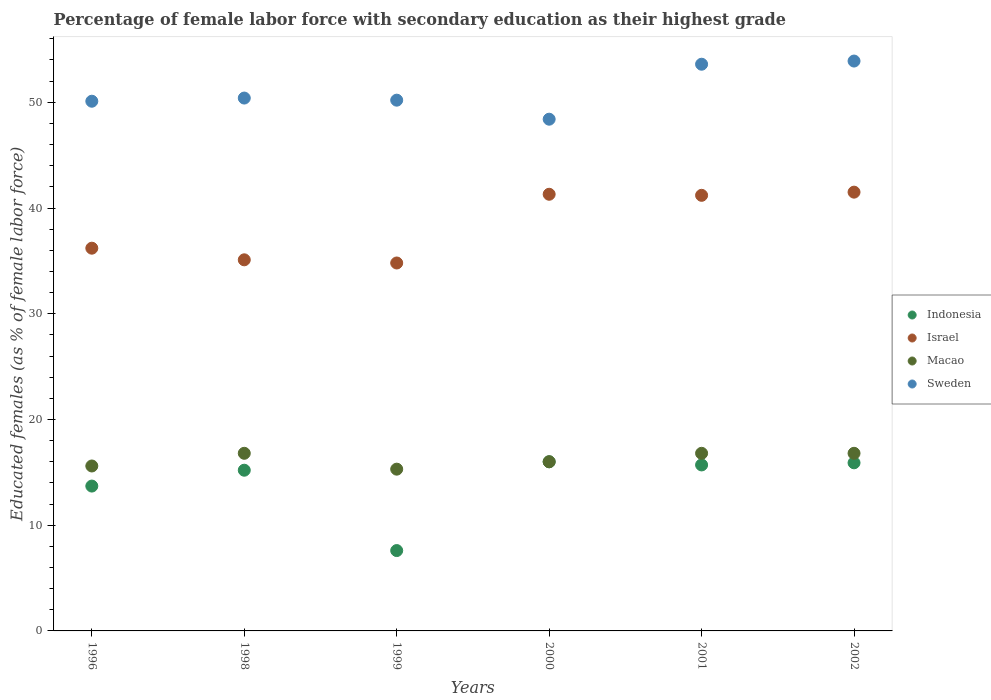How many different coloured dotlines are there?
Offer a very short reply. 4. Is the number of dotlines equal to the number of legend labels?
Give a very brief answer. Yes. What is the percentage of female labor force with secondary education in Israel in 1999?
Your answer should be compact. 34.8. Across all years, what is the maximum percentage of female labor force with secondary education in Sweden?
Your response must be concise. 53.9. Across all years, what is the minimum percentage of female labor force with secondary education in Macao?
Give a very brief answer. 15.3. In which year was the percentage of female labor force with secondary education in Israel minimum?
Offer a terse response. 1999. What is the total percentage of female labor force with secondary education in Israel in the graph?
Provide a short and direct response. 230.1. What is the difference between the percentage of female labor force with secondary education in Israel in 1998 and that in 2000?
Ensure brevity in your answer.  -6.2. What is the difference between the percentage of female labor force with secondary education in Indonesia in 1999 and the percentage of female labor force with secondary education in Israel in 2000?
Offer a terse response. -33.7. What is the average percentage of female labor force with secondary education in Macao per year?
Ensure brevity in your answer.  16.22. In the year 1999, what is the difference between the percentage of female labor force with secondary education in Indonesia and percentage of female labor force with secondary education in Macao?
Offer a very short reply. -7.7. What is the ratio of the percentage of female labor force with secondary education in Indonesia in 1998 to that in 1999?
Offer a very short reply. 2. Is the difference between the percentage of female labor force with secondary education in Indonesia in 1998 and 2001 greater than the difference between the percentage of female labor force with secondary education in Macao in 1998 and 2001?
Offer a very short reply. No. What is the difference between the highest and the second highest percentage of female labor force with secondary education in Indonesia?
Your answer should be compact. 0.1. What is the difference between the highest and the lowest percentage of female labor force with secondary education in Sweden?
Your response must be concise. 5.5. Is it the case that in every year, the sum of the percentage of female labor force with secondary education in Macao and percentage of female labor force with secondary education in Sweden  is greater than the sum of percentage of female labor force with secondary education in Indonesia and percentage of female labor force with secondary education in Israel?
Make the answer very short. Yes. Is it the case that in every year, the sum of the percentage of female labor force with secondary education in Macao and percentage of female labor force with secondary education in Israel  is greater than the percentage of female labor force with secondary education in Sweden?
Your answer should be very brief. No. Does the percentage of female labor force with secondary education in Israel monotonically increase over the years?
Offer a terse response. No. Is the percentage of female labor force with secondary education in Sweden strictly greater than the percentage of female labor force with secondary education in Macao over the years?
Your answer should be compact. Yes. Is the percentage of female labor force with secondary education in Indonesia strictly less than the percentage of female labor force with secondary education in Sweden over the years?
Offer a very short reply. Yes. How many years are there in the graph?
Give a very brief answer. 6. What is the difference between two consecutive major ticks on the Y-axis?
Keep it short and to the point. 10. Are the values on the major ticks of Y-axis written in scientific E-notation?
Your answer should be very brief. No. How are the legend labels stacked?
Provide a succinct answer. Vertical. What is the title of the graph?
Keep it short and to the point. Percentage of female labor force with secondary education as their highest grade. What is the label or title of the X-axis?
Your response must be concise. Years. What is the label or title of the Y-axis?
Give a very brief answer. Educated females (as % of female labor force). What is the Educated females (as % of female labor force) of Indonesia in 1996?
Your response must be concise. 13.7. What is the Educated females (as % of female labor force) of Israel in 1996?
Your answer should be compact. 36.2. What is the Educated females (as % of female labor force) in Macao in 1996?
Make the answer very short. 15.6. What is the Educated females (as % of female labor force) in Sweden in 1996?
Your response must be concise. 50.1. What is the Educated females (as % of female labor force) of Indonesia in 1998?
Provide a succinct answer. 15.2. What is the Educated females (as % of female labor force) of Israel in 1998?
Make the answer very short. 35.1. What is the Educated females (as % of female labor force) in Macao in 1998?
Offer a very short reply. 16.8. What is the Educated females (as % of female labor force) of Sweden in 1998?
Your answer should be very brief. 50.4. What is the Educated females (as % of female labor force) in Indonesia in 1999?
Offer a terse response. 7.6. What is the Educated females (as % of female labor force) of Israel in 1999?
Provide a succinct answer. 34.8. What is the Educated females (as % of female labor force) in Macao in 1999?
Your answer should be very brief. 15.3. What is the Educated females (as % of female labor force) in Sweden in 1999?
Keep it short and to the point. 50.2. What is the Educated females (as % of female labor force) in Indonesia in 2000?
Provide a succinct answer. 16. What is the Educated females (as % of female labor force) of Israel in 2000?
Keep it short and to the point. 41.3. What is the Educated females (as % of female labor force) of Macao in 2000?
Make the answer very short. 16. What is the Educated females (as % of female labor force) of Sweden in 2000?
Keep it short and to the point. 48.4. What is the Educated females (as % of female labor force) of Indonesia in 2001?
Keep it short and to the point. 15.7. What is the Educated females (as % of female labor force) of Israel in 2001?
Make the answer very short. 41.2. What is the Educated females (as % of female labor force) in Macao in 2001?
Offer a very short reply. 16.8. What is the Educated females (as % of female labor force) in Sweden in 2001?
Your answer should be compact. 53.6. What is the Educated females (as % of female labor force) of Indonesia in 2002?
Your answer should be very brief. 15.9. What is the Educated females (as % of female labor force) of Israel in 2002?
Give a very brief answer. 41.5. What is the Educated females (as % of female labor force) in Macao in 2002?
Ensure brevity in your answer.  16.8. What is the Educated females (as % of female labor force) of Sweden in 2002?
Make the answer very short. 53.9. Across all years, what is the maximum Educated females (as % of female labor force) in Indonesia?
Provide a short and direct response. 16. Across all years, what is the maximum Educated females (as % of female labor force) of Israel?
Your answer should be very brief. 41.5. Across all years, what is the maximum Educated females (as % of female labor force) of Macao?
Make the answer very short. 16.8. Across all years, what is the maximum Educated females (as % of female labor force) in Sweden?
Provide a short and direct response. 53.9. Across all years, what is the minimum Educated females (as % of female labor force) in Indonesia?
Keep it short and to the point. 7.6. Across all years, what is the minimum Educated females (as % of female labor force) of Israel?
Provide a short and direct response. 34.8. Across all years, what is the minimum Educated females (as % of female labor force) of Macao?
Provide a short and direct response. 15.3. Across all years, what is the minimum Educated females (as % of female labor force) of Sweden?
Your response must be concise. 48.4. What is the total Educated females (as % of female labor force) in Indonesia in the graph?
Offer a very short reply. 84.1. What is the total Educated females (as % of female labor force) of Israel in the graph?
Give a very brief answer. 230.1. What is the total Educated females (as % of female labor force) in Macao in the graph?
Your response must be concise. 97.3. What is the total Educated females (as % of female labor force) in Sweden in the graph?
Your response must be concise. 306.6. What is the difference between the Educated females (as % of female labor force) in Indonesia in 1996 and that in 1998?
Provide a short and direct response. -1.5. What is the difference between the Educated females (as % of female labor force) of Israel in 1996 and that in 1998?
Offer a terse response. 1.1. What is the difference between the Educated females (as % of female labor force) of Macao in 1996 and that in 1998?
Offer a very short reply. -1.2. What is the difference between the Educated females (as % of female labor force) of Sweden in 1996 and that in 1998?
Offer a very short reply. -0.3. What is the difference between the Educated females (as % of female labor force) in Macao in 1996 and that in 1999?
Provide a short and direct response. 0.3. What is the difference between the Educated females (as % of female labor force) of Sweden in 1996 and that in 1999?
Ensure brevity in your answer.  -0.1. What is the difference between the Educated females (as % of female labor force) in Macao in 1996 and that in 2000?
Provide a succinct answer. -0.4. What is the difference between the Educated females (as % of female labor force) of Sweden in 1996 and that in 2000?
Provide a short and direct response. 1.7. What is the difference between the Educated females (as % of female labor force) in Macao in 1996 and that in 2001?
Provide a succinct answer. -1.2. What is the difference between the Educated females (as % of female labor force) in Sweden in 1996 and that in 2001?
Your answer should be very brief. -3.5. What is the difference between the Educated females (as % of female labor force) in Sweden in 1996 and that in 2002?
Keep it short and to the point. -3.8. What is the difference between the Educated females (as % of female labor force) in Indonesia in 1998 and that in 1999?
Your answer should be very brief. 7.6. What is the difference between the Educated females (as % of female labor force) of Israel in 1998 and that in 1999?
Offer a very short reply. 0.3. What is the difference between the Educated females (as % of female labor force) in Indonesia in 1998 and that in 2000?
Make the answer very short. -0.8. What is the difference between the Educated females (as % of female labor force) of Sweden in 1998 and that in 2000?
Make the answer very short. 2. What is the difference between the Educated females (as % of female labor force) in Indonesia in 1998 and that in 2001?
Offer a terse response. -0.5. What is the difference between the Educated females (as % of female labor force) in Sweden in 1998 and that in 2001?
Your answer should be very brief. -3.2. What is the difference between the Educated females (as % of female labor force) in Indonesia in 1998 and that in 2002?
Give a very brief answer. -0.7. What is the difference between the Educated females (as % of female labor force) of Israel in 1998 and that in 2002?
Your answer should be very brief. -6.4. What is the difference between the Educated females (as % of female labor force) of Macao in 1999 and that in 2000?
Give a very brief answer. -0.7. What is the difference between the Educated females (as % of female labor force) in Indonesia in 1999 and that in 2001?
Your answer should be compact. -8.1. What is the difference between the Educated females (as % of female labor force) of Macao in 1999 and that in 2001?
Provide a succinct answer. -1.5. What is the difference between the Educated females (as % of female labor force) in Sweden in 1999 and that in 2001?
Provide a short and direct response. -3.4. What is the difference between the Educated females (as % of female labor force) of Indonesia in 1999 and that in 2002?
Your answer should be compact. -8.3. What is the difference between the Educated females (as % of female labor force) of Israel in 1999 and that in 2002?
Ensure brevity in your answer.  -6.7. What is the difference between the Educated females (as % of female labor force) in Macao in 1999 and that in 2002?
Offer a very short reply. -1.5. What is the difference between the Educated females (as % of female labor force) of Sweden in 1999 and that in 2002?
Provide a succinct answer. -3.7. What is the difference between the Educated females (as % of female labor force) in Indonesia in 2000 and that in 2001?
Offer a terse response. 0.3. What is the difference between the Educated females (as % of female labor force) of Israel in 2000 and that in 2001?
Your response must be concise. 0.1. What is the difference between the Educated females (as % of female labor force) of Sweden in 2000 and that in 2001?
Provide a short and direct response. -5.2. What is the difference between the Educated females (as % of female labor force) in Indonesia in 2000 and that in 2002?
Make the answer very short. 0.1. What is the difference between the Educated females (as % of female labor force) of Indonesia in 2001 and that in 2002?
Your response must be concise. -0.2. What is the difference between the Educated females (as % of female labor force) of Macao in 2001 and that in 2002?
Make the answer very short. 0. What is the difference between the Educated females (as % of female labor force) of Indonesia in 1996 and the Educated females (as % of female labor force) of Israel in 1998?
Provide a short and direct response. -21.4. What is the difference between the Educated females (as % of female labor force) in Indonesia in 1996 and the Educated females (as % of female labor force) in Macao in 1998?
Give a very brief answer. -3.1. What is the difference between the Educated females (as % of female labor force) of Indonesia in 1996 and the Educated females (as % of female labor force) of Sweden in 1998?
Give a very brief answer. -36.7. What is the difference between the Educated females (as % of female labor force) in Israel in 1996 and the Educated females (as % of female labor force) in Macao in 1998?
Your answer should be very brief. 19.4. What is the difference between the Educated females (as % of female labor force) of Macao in 1996 and the Educated females (as % of female labor force) of Sweden in 1998?
Offer a very short reply. -34.8. What is the difference between the Educated females (as % of female labor force) in Indonesia in 1996 and the Educated females (as % of female labor force) in Israel in 1999?
Your answer should be very brief. -21.1. What is the difference between the Educated females (as % of female labor force) in Indonesia in 1996 and the Educated females (as % of female labor force) in Sweden in 1999?
Keep it short and to the point. -36.5. What is the difference between the Educated females (as % of female labor force) in Israel in 1996 and the Educated females (as % of female labor force) in Macao in 1999?
Your response must be concise. 20.9. What is the difference between the Educated females (as % of female labor force) of Israel in 1996 and the Educated females (as % of female labor force) of Sweden in 1999?
Provide a succinct answer. -14. What is the difference between the Educated females (as % of female labor force) of Macao in 1996 and the Educated females (as % of female labor force) of Sweden in 1999?
Offer a terse response. -34.6. What is the difference between the Educated females (as % of female labor force) of Indonesia in 1996 and the Educated females (as % of female labor force) of Israel in 2000?
Offer a very short reply. -27.6. What is the difference between the Educated females (as % of female labor force) in Indonesia in 1996 and the Educated females (as % of female labor force) in Macao in 2000?
Offer a very short reply. -2.3. What is the difference between the Educated females (as % of female labor force) in Indonesia in 1996 and the Educated females (as % of female labor force) in Sweden in 2000?
Offer a terse response. -34.7. What is the difference between the Educated females (as % of female labor force) in Israel in 1996 and the Educated females (as % of female labor force) in Macao in 2000?
Provide a short and direct response. 20.2. What is the difference between the Educated females (as % of female labor force) in Israel in 1996 and the Educated females (as % of female labor force) in Sweden in 2000?
Offer a terse response. -12.2. What is the difference between the Educated females (as % of female labor force) in Macao in 1996 and the Educated females (as % of female labor force) in Sweden in 2000?
Your response must be concise. -32.8. What is the difference between the Educated females (as % of female labor force) in Indonesia in 1996 and the Educated females (as % of female labor force) in Israel in 2001?
Ensure brevity in your answer.  -27.5. What is the difference between the Educated females (as % of female labor force) in Indonesia in 1996 and the Educated females (as % of female labor force) in Sweden in 2001?
Ensure brevity in your answer.  -39.9. What is the difference between the Educated females (as % of female labor force) of Israel in 1996 and the Educated females (as % of female labor force) of Sweden in 2001?
Keep it short and to the point. -17.4. What is the difference between the Educated females (as % of female labor force) in Macao in 1996 and the Educated females (as % of female labor force) in Sweden in 2001?
Offer a very short reply. -38. What is the difference between the Educated females (as % of female labor force) of Indonesia in 1996 and the Educated females (as % of female labor force) of Israel in 2002?
Provide a succinct answer. -27.8. What is the difference between the Educated females (as % of female labor force) of Indonesia in 1996 and the Educated females (as % of female labor force) of Macao in 2002?
Your response must be concise. -3.1. What is the difference between the Educated females (as % of female labor force) in Indonesia in 1996 and the Educated females (as % of female labor force) in Sweden in 2002?
Provide a succinct answer. -40.2. What is the difference between the Educated females (as % of female labor force) of Israel in 1996 and the Educated females (as % of female labor force) of Macao in 2002?
Your response must be concise. 19.4. What is the difference between the Educated females (as % of female labor force) in Israel in 1996 and the Educated females (as % of female labor force) in Sweden in 2002?
Provide a short and direct response. -17.7. What is the difference between the Educated females (as % of female labor force) of Macao in 1996 and the Educated females (as % of female labor force) of Sweden in 2002?
Offer a very short reply. -38.3. What is the difference between the Educated females (as % of female labor force) of Indonesia in 1998 and the Educated females (as % of female labor force) of Israel in 1999?
Make the answer very short. -19.6. What is the difference between the Educated females (as % of female labor force) of Indonesia in 1998 and the Educated females (as % of female labor force) of Sweden in 1999?
Offer a terse response. -35. What is the difference between the Educated females (as % of female labor force) of Israel in 1998 and the Educated females (as % of female labor force) of Macao in 1999?
Your answer should be very brief. 19.8. What is the difference between the Educated females (as % of female labor force) in Israel in 1998 and the Educated females (as % of female labor force) in Sweden in 1999?
Offer a very short reply. -15.1. What is the difference between the Educated females (as % of female labor force) of Macao in 1998 and the Educated females (as % of female labor force) of Sweden in 1999?
Make the answer very short. -33.4. What is the difference between the Educated females (as % of female labor force) of Indonesia in 1998 and the Educated females (as % of female labor force) of Israel in 2000?
Provide a short and direct response. -26.1. What is the difference between the Educated females (as % of female labor force) in Indonesia in 1998 and the Educated females (as % of female labor force) in Macao in 2000?
Give a very brief answer. -0.8. What is the difference between the Educated females (as % of female labor force) in Indonesia in 1998 and the Educated females (as % of female labor force) in Sweden in 2000?
Offer a very short reply. -33.2. What is the difference between the Educated females (as % of female labor force) in Macao in 1998 and the Educated females (as % of female labor force) in Sweden in 2000?
Offer a very short reply. -31.6. What is the difference between the Educated females (as % of female labor force) in Indonesia in 1998 and the Educated females (as % of female labor force) in Macao in 2001?
Offer a terse response. -1.6. What is the difference between the Educated females (as % of female labor force) of Indonesia in 1998 and the Educated females (as % of female labor force) of Sweden in 2001?
Make the answer very short. -38.4. What is the difference between the Educated females (as % of female labor force) in Israel in 1998 and the Educated females (as % of female labor force) in Sweden in 2001?
Provide a succinct answer. -18.5. What is the difference between the Educated females (as % of female labor force) in Macao in 1998 and the Educated females (as % of female labor force) in Sweden in 2001?
Give a very brief answer. -36.8. What is the difference between the Educated females (as % of female labor force) in Indonesia in 1998 and the Educated females (as % of female labor force) in Israel in 2002?
Ensure brevity in your answer.  -26.3. What is the difference between the Educated females (as % of female labor force) of Indonesia in 1998 and the Educated females (as % of female labor force) of Sweden in 2002?
Make the answer very short. -38.7. What is the difference between the Educated females (as % of female labor force) of Israel in 1998 and the Educated females (as % of female labor force) of Macao in 2002?
Give a very brief answer. 18.3. What is the difference between the Educated females (as % of female labor force) in Israel in 1998 and the Educated females (as % of female labor force) in Sweden in 2002?
Provide a succinct answer. -18.8. What is the difference between the Educated females (as % of female labor force) of Macao in 1998 and the Educated females (as % of female labor force) of Sweden in 2002?
Give a very brief answer. -37.1. What is the difference between the Educated females (as % of female labor force) of Indonesia in 1999 and the Educated females (as % of female labor force) of Israel in 2000?
Give a very brief answer. -33.7. What is the difference between the Educated females (as % of female labor force) in Indonesia in 1999 and the Educated females (as % of female labor force) in Macao in 2000?
Your answer should be very brief. -8.4. What is the difference between the Educated females (as % of female labor force) in Indonesia in 1999 and the Educated females (as % of female labor force) in Sweden in 2000?
Your response must be concise. -40.8. What is the difference between the Educated females (as % of female labor force) of Israel in 1999 and the Educated females (as % of female labor force) of Sweden in 2000?
Your answer should be compact. -13.6. What is the difference between the Educated females (as % of female labor force) in Macao in 1999 and the Educated females (as % of female labor force) in Sweden in 2000?
Your response must be concise. -33.1. What is the difference between the Educated females (as % of female labor force) of Indonesia in 1999 and the Educated females (as % of female labor force) of Israel in 2001?
Your answer should be compact. -33.6. What is the difference between the Educated females (as % of female labor force) in Indonesia in 1999 and the Educated females (as % of female labor force) in Sweden in 2001?
Keep it short and to the point. -46. What is the difference between the Educated females (as % of female labor force) in Israel in 1999 and the Educated females (as % of female labor force) in Macao in 2001?
Provide a succinct answer. 18. What is the difference between the Educated females (as % of female labor force) of Israel in 1999 and the Educated females (as % of female labor force) of Sweden in 2001?
Your response must be concise. -18.8. What is the difference between the Educated females (as % of female labor force) of Macao in 1999 and the Educated females (as % of female labor force) of Sweden in 2001?
Offer a very short reply. -38.3. What is the difference between the Educated females (as % of female labor force) of Indonesia in 1999 and the Educated females (as % of female labor force) of Israel in 2002?
Make the answer very short. -33.9. What is the difference between the Educated females (as % of female labor force) of Indonesia in 1999 and the Educated females (as % of female labor force) of Sweden in 2002?
Your answer should be very brief. -46.3. What is the difference between the Educated females (as % of female labor force) of Israel in 1999 and the Educated females (as % of female labor force) of Macao in 2002?
Provide a succinct answer. 18. What is the difference between the Educated females (as % of female labor force) of Israel in 1999 and the Educated females (as % of female labor force) of Sweden in 2002?
Give a very brief answer. -19.1. What is the difference between the Educated females (as % of female labor force) in Macao in 1999 and the Educated females (as % of female labor force) in Sweden in 2002?
Provide a short and direct response. -38.6. What is the difference between the Educated females (as % of female labor force) in Indonesia in 2000 and the Educated females (as % of female labor force) in Israel in 2001?
Keep it short and to the point. -25.2. What is the difference between the Educated females (as % of female labor force) in Indonesia in 2000 and the Educated females (as % of female labor force) in Sweden in 2001?
Your answer should be very brief. -37.6. What is the difference between the Educated females (as % of female labor force) in Israel in 2000 and the Educated females (as % of female labor force) in Macao in 2001?
Provide a short and direct response. 24.5. What is the difference between the Educated females (as % of female labor force) in Israel in 2000 and the Educated females (as % of female labor force) in Sweden in 2001?
Keep it short and to the point. -12.3. What is the difference between the Educated females (as % of female labor force) of Macao in 2000 and the Educated females (as % of female labor force) of Sweden in 2001?
Your response must be concise. -37.6. What is the difference between the Educated females (as % of female labor force) of Indonesia in 2000 and the Educated females (as % of female labor force) of Israel in 2002?
Keep it short and to the point. -25.5. What is the difference between the Educated females (as % of female labor force) in Indonesia in 2000 and the Educated females (as % of female labor force) in Sweden in 2002?
Your answer should be very brief. -37.9. What is the difference between the Educated females (as % of female labor force) in Macao in 2000 and the Educated females (as % of female labor force) in Sweden in 2002?
Offer a terse response. -37.9. What is the difference between the Educated females (as % of female labor force) in Indonesia in 2001 and the Educated females (as % of female labor force) in Israel in 2002?
Your answer should be compact. -25.8. What is the difference between the Educated females (as % of female labor force) of Indonesia in 2001 and the Educated females (as % of female labor force) of Macao in 2002?
Make the answer very short. -1.1. What is the difference between the Educated females (as % of female labor force) in Indonesia in 2001 and the Educated females (as % of female labor force) in Sweden in 2002?
Ensure brevity in your answer.  -38.2. What is the difference between the Educated females (as % of female labor force) in Israel in 2001 and the Educated females (as % of female labor force) in Macao in 2002?
Keep it short and to the point. 24.4. What is the difference between the Educated females (as % of female labor force) in Israel in 2001 and the Educated females (as % of female labor force) in Sweden in 2002?
Give a very brief answer. -12.7. What is the difference between the Educated females (as % of female labor force) in Macao in 2001 and the Educated females (as % of female labor force) in Sweden in 2002?
Your answer should be compact. -37.1. What is the average Educated females (as % of female labor force) in Indonesia per year?
Your answer should be very brief. 14.02. What is the average Educated females (as % of female labor force) in Israel per year?
Provide a short and direct response. 38.35. What is the average Educated females (as % of female labor force) of Macao per year?
Give a very brief answer. 16.22. What is the average Educated females (as % of female labor force) in Sweden per year?
Offer a very short reply. 51.1. In the year 1996, what is the difference between the Educated females (as % of female labor force) in Indonesia and Educated females (as % of female labor force) in Israel?
Your answer should be compact. -22.5. In the year 1996, what is the difference between the Educated females (as % of female labor force) in Indonesia and Educated females (as % of female labor force) in Sweden?
Keep it short and to the point. -36.4. In the year 1996, what is the difference between the Educated females (as % of female labor force) in Israel and Educated females (as % of female labor force) in Macao?
Ensure brevity in your answer.  20.6. In the year 1996, what is the difference between the Educated females (as % of female labor force) in Macao and Educated females (as % of female labor force) in Sweden?
Your response must be concise. -34.5. In the year 1998, what is the difference between the Educated females (as % of female labor force) of Indonesia and Educated females (as % of female labor force) of Israel?
Ensure brevity in your answer.  -19.9. In the year 1998, what is the difference between the Educated females (as % of female labor force) of Indonesia and Educated females (as % of female labor force) of Macao?
Make the answer very short. -1.6. In the year 1998, what is the difference between the Educated females (as % of female labor force) in Indonesia and Educated females (as % of female labor force) in Sweden?
Your answer should be very brief. -35.2. In the year 1998, what is the difference between the Educated females (as % of female labor force) of Israel and Educated females (as % of female labor force) of Macao?
Ensure brevity in your answer.  18.3. In the year 1998, what is the difference between the Educated females (as % of female labor force) of Israel and Educated females (as % of female labor force) of Sweden?
Make the answer very short. -15.3. In the year 1998, what is the difference between the Educated females (as % of female labor force) in Macao and Educated females (as % of female labor force) in Sweden?
Provide a short and direct response. -33.6. In the year 1999, what is the difference between the Educated females (as % of female labor force) of Indonesia and Educated females (as % of female labor force) of Israel?
Provide a succinct answer. -27.2. In the year 1999, what is the difference between the Educated females (as % of female labor force) in Indonesia and Educated females (as % of female labor force) in Sweden?
Provide a succinct answer. -42.6. In the year 1999, what is the difference between the Educated females (as % of female labor force) of Israel and Educated females (as % of female labor force) of Macao?
Offer a very short reply. 19.5. In the year 1999, what is the difference between the Educated females (as % of female labor force) of Israel and Educated females (as % of female labor force) of Sweden?
Make the answer very short. -15.4. In the year 1999, what is the difference between the Educated females (as % of female labor force) of Macao and Educated females (as % of female labor force) of Sweden?
Make the answer very short. -34.9. In the year 2000, what is the difference between the Educated females (as % of female labor force) of Indonesia and Educated females (as % of female labor force) of Israel?
Keep it short and to the point. -25.3. In the year 2000, what is the difference between the Educated females (as % of female labor force) of Indonesia and Educated females (as % of female labor force) of Sweden?
Keep it short and to the point. -32.4. In the year 2000, what is the difference between the Educated females (as % of female labor force) of Israel and Educated females (as % of female labor force) of Macao?
Offer a terse response. 25.3. In the year 2000, what is the difference between the Educated females (as % of female labor force) of Israel and Educated females (as % of female labor force) of Sweden?
Your answer should be very brief. -7.1. In the year 2000, what is the difference between the Educated females (as % of female labor force) of Macao and Educated females (as % of female labor force) of Sweden?
Your answer should be compact. -32.4. In the year 2001, what is the difference between the Educated females (as % of female labor force) in Indonesia and Educated females (as % of female labor force) in Israel?
Provide a short and direct response. -25.5. In the year 2001, what is the difference between the Educated females (as % of female labor force) of Indonesia and Educated females (as % of female labor force) of Sweden?
Your response must be concise. -37.9. In the year 2001, what is the difference between the Educated females (as % of female labor force) in Israel and Educated females (as % of female labor force) in Macao?
Your answer should be very brief. 24.4. In the year 2001, what is the difference between the Educated females (as % of female labor force) in Israel and Educated females (as % of female labor force) in Sweden?
Give a very brief answer. -12.4. In the year 2001, what is the difference between the Educated females (as % of female labor force) in Macao and Educated females (as % of female labor force) in Sweden?
Provide a succinct answer. -36.8. In the year 2002, what is the difference between the Educated females (as % of female labor force) of Indonesia and Educated females (as % of female labor force) of Israel?
Give a very brief answer. -25.6. In the year 2002, what is the difference between the Educated females (as % of female labor force) in Indonesia and Educated females (as % of female labor force) in Sweden?
Ensure brevity in your answer.  -38. In the year 2002, what is the difference between the Educated females (as % of female labor force) of Israel and Educated females (as % of female labor force) of Macao?
Your answer should be compact. 24.7. In the year 2002, what is the difference between the Educated females (as % of female labor force) in Israel and Educated females (as % of female labor force) in Sweden?
Keep it short and to the point. -12.4. In the year 2002, what is the difference between the Educated females (as % of female labor force) in Macao and Educated females (as % of female labor force) in Sweden?
Your answer should be compact. -37.1. What is the ratio of the Educated females (as % of female labor force) of Indonesia in 1996 to that in 1998?
Your answer should be very brief. 0.9. What is the ratio of the Educated females (as % of female labor force) of Israel in 1996 to that in 1998?
Keep it short and to the point. 1.03. What is the ratio of the Educated females (as % of female labor force) of Sweden in 1996 to that in 1998?
Offer a terse response. 0.99. What is the ratio of the Educated females (as % of female labor force) in Indonesia in 1996 to that in 1999?
Provide a succinct answer. 1.8. What is the ratio of the Educated females (as % of female labor force) in Israel in 1996 to that in 1999?
Your answer should be compact. 1.04. What is the ratio of the Educated females (as % of female labor force) in Macao in 1996 to that in 1999?
Your answer should be very brief. 1.02. What is the ratio of the Educated females (as % of female labor force) of Sweden in 1996 to that in 1999?
Provide a succinct answer. 1. What is the ratio of the Educated females (as % of female labor force) in Indonesia in 1996 to that in 2000?
Offer a terse response. 0.86. What is the ratio of the Educated females (as % of female labor force) of Israel in 1996 to that in 2000?
Provide a short and direct response. 0.88. What is the ratio of the Educated females (as % of female labor force) of Sweden in 1996 to that in 2000?
Provide a succinct answer. 1.04. What is the ratio of the Educated females (as % of female labor force) of Indonesia in 1996 to that in 2001?
Provide a succinct answer. 0.87. What is the ratio of the Educated females (as % of female labor force) of Israel in 1996 to that in 2001?
Offer a terse response. 0.88. What is the ratio of the Educated females (as % of female labor force) of Sweden in 1996 to that in 2001?
Make the answer very short. 0.93. What is the ratio of the Educated females (as % of female labor force) of Indonesia in 1996 to that in 2002?
Provide a succinct answer. 0.86. What is the ratio of the Educated females (as % of female labor force) of Israel in 1996 to that in 2002?
Ensure brevity in your answer.  0.87. What is the ratio of the Educated females (as % of female labor force) in Sweden in 1996 to that in 2002?
Your answer should be compact. 0.93. What is the ratio of the Educated females (as % of female labor force) in Indonesia in 1998 to that in 1999?
Your answer should be very brief. 2. What is the ratio of the Educated females (as % of female labor force) of Israel in 1998 to that in 1999?
Your response must be concise. 1.01. What is the ratio of the Educated females (as % of female labor force) in Macao in 1998 to that in 1999?
Provide a succinct answer. 1.1. What is the ratio of the Educated females (as % of female labor force) in Israel in 1998 to that in 2000?
Provide a succinct answer. 0.85. What is the ratio of the Educated females (as % of female labor force) of Sweden in 1998 to that in 2000?
Your answer should be very brief. 1.04. What is the ratio of the Educated females (as % of female labor force) of Indonesia in 1998 to that in 2001?
Ensure brevity in your answer.  0.97. What is the ratio of the Educated females (as % of female labor force) of Israel in 1998 to that in 2001?
Give a very brief answer. 0.85. What is the ratio of the Educated females (as % of female labor force) in Sweden in 1998 to that in 2001?
Provide a short and direct response. 0.94. What is the ratio of the Educated females (as % of female labor force) in Indonesia in 1998 to that in 2002?
Ensure brevity in your answer.  0.96. What is the ratio of the Educated females (as % of female labor force) of Israel in 1998 to that in 2002?
Your response must be concise. 0.85. What is the ratio of the Educated females (as % of female labor force) of Macao in 1998 to that in 2002?
Your answer should be very brief. 1. What is the ratio of the Educated females (as % of female labor force) of Sweden in 1998 to that in 2002?
Keep it short and to the point. 0.94. What is the ratio of the Educated females (as % of female labor force) in Indonesia in 1999 to that in 2000?
Your answer should be very brief. 0.47. What is the ratio of the Educated females (as % of female labor force) of Israel in 1999 to that in 2000?
Make the answer very short. 0.84. What is the ratio of the Educated females (as % of female labor force) of Macao in 1999 to that in 2000?
Provide a succinct answer. 0.96. What is the ratio of the Educated females (as % of female labor force) in Sweden in 1999 to that in 2000?
Your answer should be very brief. 1.04. What is the ratio of the Educated females (as % of female labor force) of Indonesia in 1999 to that in 2001?
Ensure brevity in your answer.  0.48. What is the ratio of the Educated females (as % of female labor force) in Israel in 1999 to that in 2001?
Your answer should be compact. 0.84. What is the ratio of the Educated females (as % of female labor force) of Macao in 1999 to that in 2001?
Make the answer very short. 0.91. What is the ratio of the Educated females (as % of female labor force) in Sweden in 1999 to that in 2001?
Give a very brief answer. 0.94. What is the ratio of the Educated females (as % of female labor force) of Indonesia in 1999 to that in 2002?
Keep it short and to the point. 0.48. What is the ratio of the Educated females (as % of female labor force) of Israel in 1999 to that in 2002?
Your answer should be very brief. 0.84. What is the ratio of the Educated females (as % of female labor force) of Macao in 1999 to that in 2002?
Offer a terse response. 0.91. What is the ratio of the Educated females (as % of female labor force) of Sweden in 1999 to that in 2002?
Keep it short and to the point. 0.93. What is the ratio of the Educated females (as % of female labor force) in Indonesia in 2000 to that in 2001?
Give a very brief answer. 1.02. What is the ratio of the Educated females (as % of female labor force) of Macao in 2000 to that in 2001?
Make the answer very short. 0.95. What is the ratio of the Educated females (as % of female labor force) in Sweden in 2000 to that in 2001?
Provide a succinct answer. 0.9. What is the ratio of the Educated females (as % of female labor force) of Indonesia in 2000 to that in 2002?
Offer a very short reply. 1.01. What is the ratio of the Educated females (as % of female labor force) in Israel in 2000 to that in 2002?
Offer a very short reply. 1. What is the ratio of the Educated females (as % of female labor force) in Sweden in 2000 to that in 2002?
Offer a very short reply. 0.9. What is the ratio of the Educated females (as % of female labor force) in Indonesia in 2001 to that in 2002?
Your answer should be very brief. 0.99. What is the ratio of the Educated females (as % of female labor force) in Macao in 2001 to that in 2002?
Your response must be concise. 1. What is the difference between the highest and the second highest Educated females (as % of female labor force) in Indonesia?
Make the answer very short. 0.1. What is the difference between the highest and the second highest Educated females (as % of female labor force) in Macao?
Provide a succinct answer. 0. What is the difference between the highest and the lowest Educated females (as % of female labor force) of Indonesia?
Offer a very short reply. 8.4. What is the difference between the highest and the lowest Educated females (as % of female labor force) in Macao?
Ensure brevity in your answer.  1.5. What is the difference between the highest and the lowest Educated females (as % of female labor force) in Sweden?
Your answer should be very brief. 5.5. 